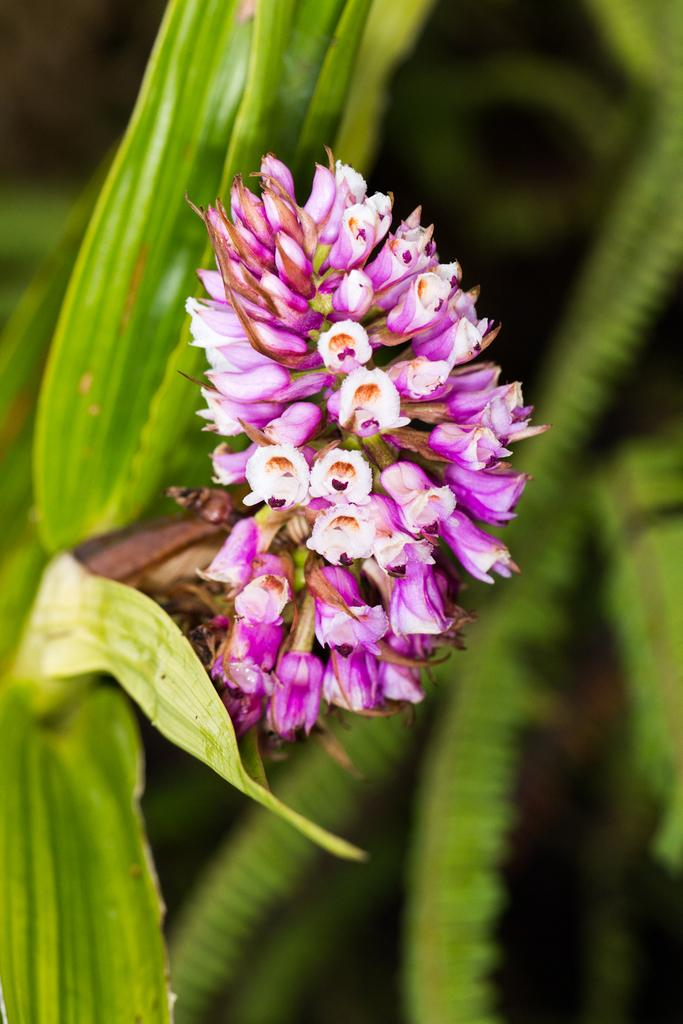What colors are the flowers on the plant in the image? The flowers on the plant are pink and white. Can you describe the background of the image? The background of the image is blurred. What type of elbow can be seen in the image? There is no elbow present in the image; it features a plant with pink and white flowers against a blurred background. 